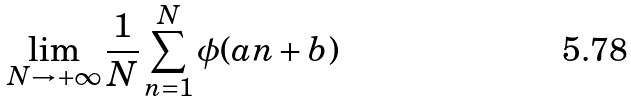Convert formula to latex. <formula><loc_0><loc_0><loc_500><loc_500>\lim _ { N \to + \infty } \frac { 1 } { N } \sum _ { n = 1 } ^ { N } \phi ( a n + b )</formula> 